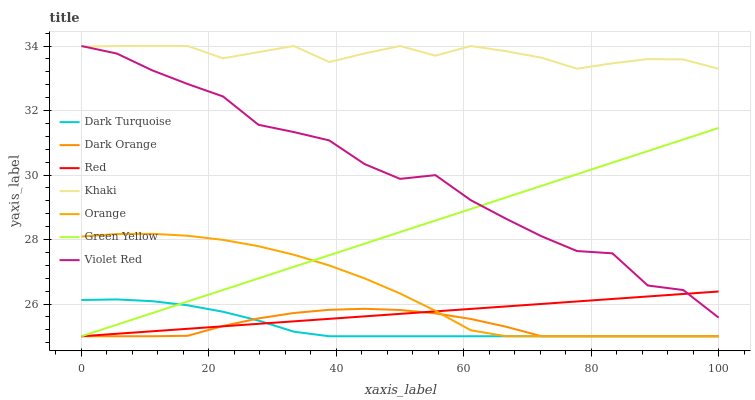Does Violet Red have the minimum area under the curve?
Answer yes or no. No. Does Violet Red have the maximum area under the curve?
Answer yes or no. No. Is Khaki the smoothest?
Answer yes or no. No. Is Khaki the roughest?
Answer yes or no. No. Does Violet Red have the lowest value?
Answer yes or no. No. Does Dark Turquoise have the highest value?
Answer yes or no. No. Is Dark Orange less than Violet Red?
Answer yes or no. Yes. Is Khaki greater than Dark Orange?
Answer yes or no. Yes. Does Dark Orange intersect Violet Red?
Answer yes or no. No. 